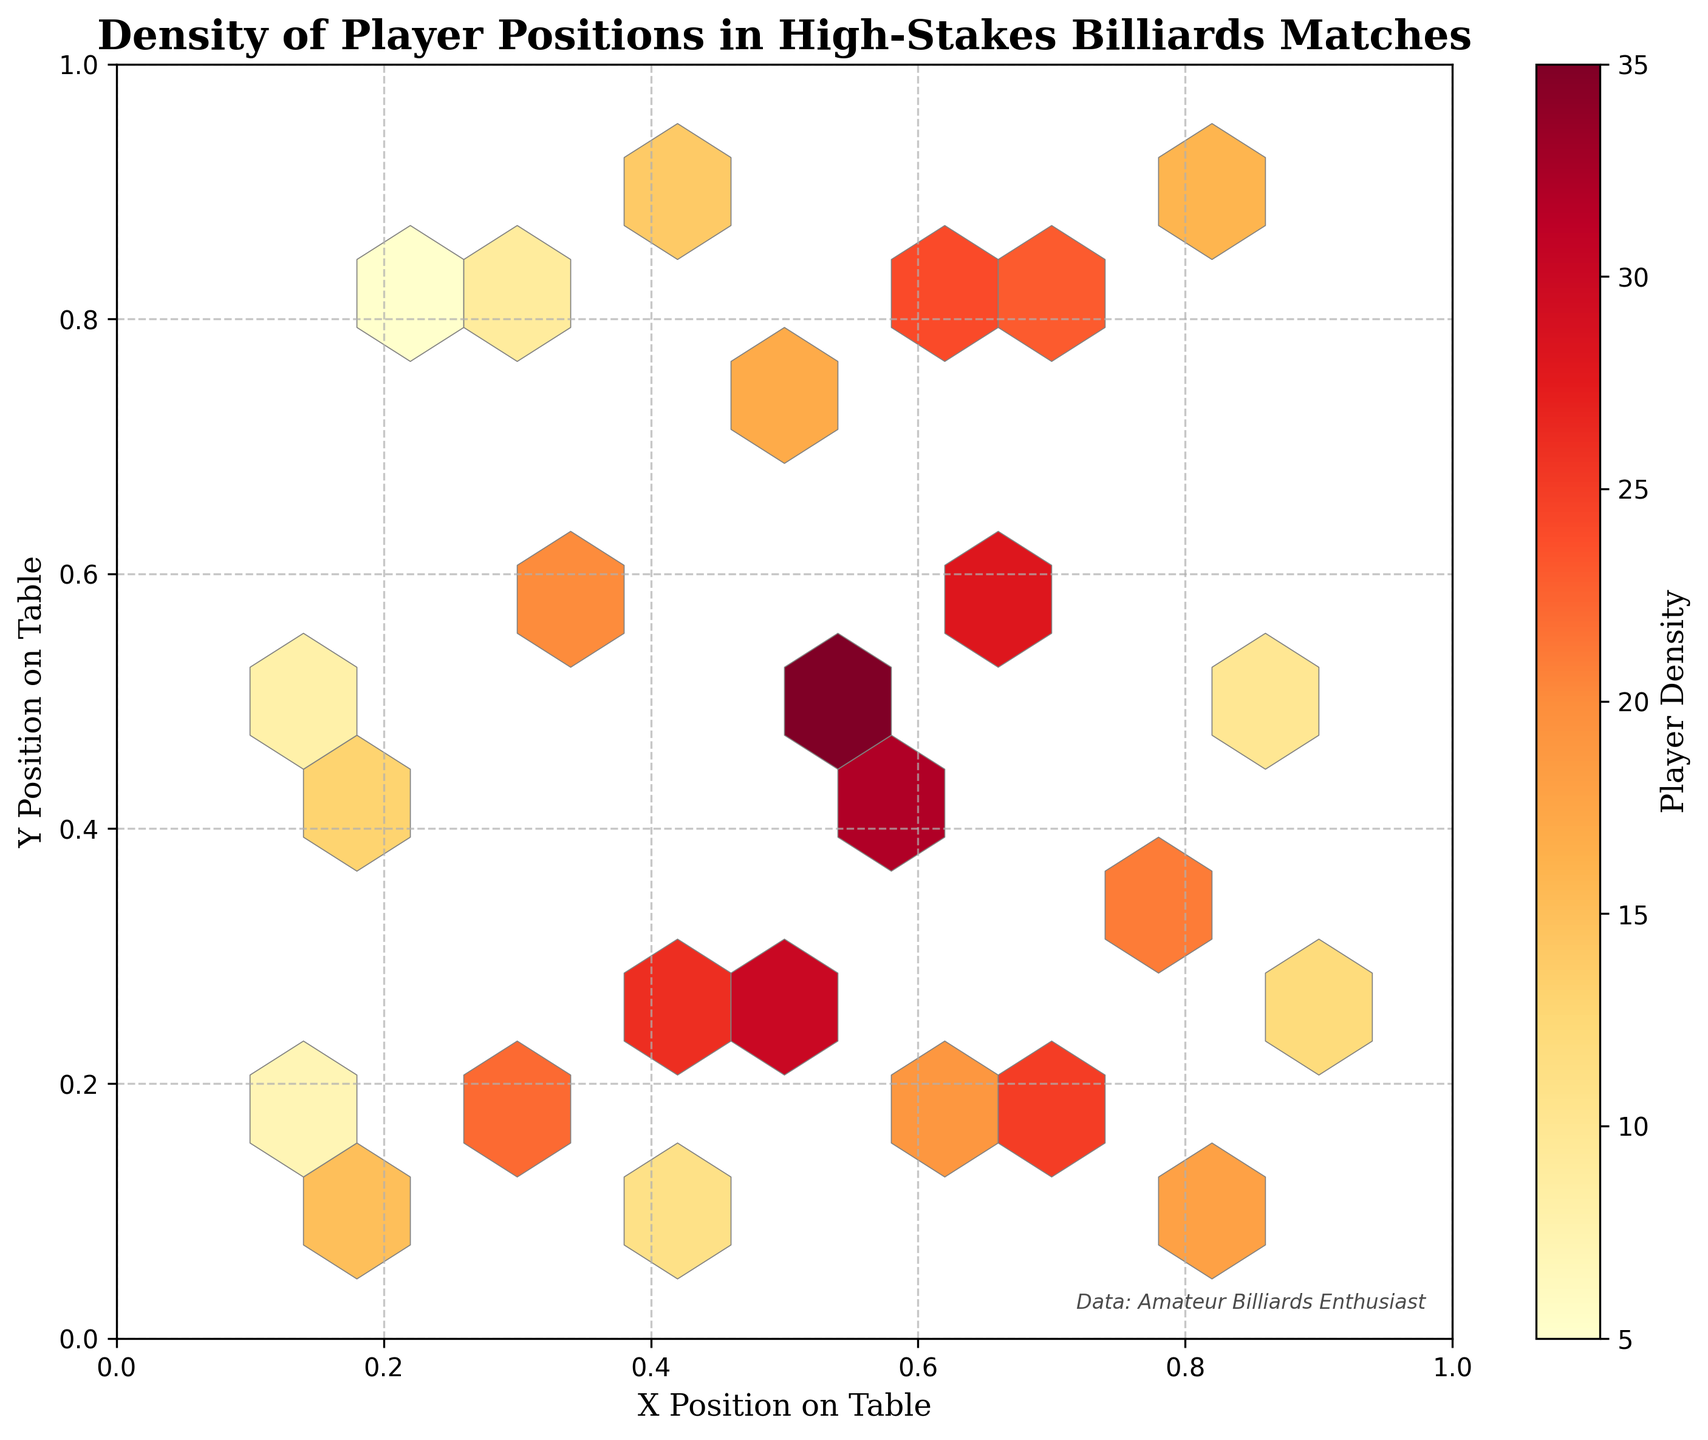What's the title of the plot? The title is located at the top of the plot. It typically describes what the graph is about.
Answer: Density of Player Positions in High-Stakes Billiards Matches What does the colorbar represent? The colorbar is used to represent the density of players in the plot. It shows how the color intensity corresponds to different density values.
Answer: Player Density What is the color for the highest density? The hexagons in the plot are colored according to player density. The most intense color in the colorbar represents the highest density.
Answer: Dark Red Where do players tend to position themselves most frequently on the table? To identify where players position themselves most frequently, look at where the hexagons are most densely packed and where the color intensity is highest.
Answer: Around (0.5, 0.5) Is there a noticeable pattern in player positions? By observing the distribution of hexagon densities across the plot, one can determine if there's a pattern or clustering of positions on the table.
Answer: Yes, there is a clustering around the center Which axis represents the X position on the table? The X-axis label near the bottom of the plot indicates which axis represents the X position.
Answer: The horizontal axis How does the player density change from the center to the edges of the table? By comparing the color intensities of hexagons from the center to the edges, one can infer changes in player density.
Answer: The density decreases from the center to the edges Are there any areas with very low player density? Check for hexagons that are lightly colored or nearly white, as these indicate areas with low player density.
Answer: Yes, towards the edges How many bins are there across the X-axis? Count the number of vertical strips of hexagons across the X-axis, as these represent the bins.
Answer: 10 Between (0.3, 0.2) and (0.7, 0.6), which area has a higher player density? Compare the color intensity of the hexagon at (0.3, 0.2) with that at (0.7, 0.6). The higher intensity suggests greater density.
Answer: (0.7, 0.6) 